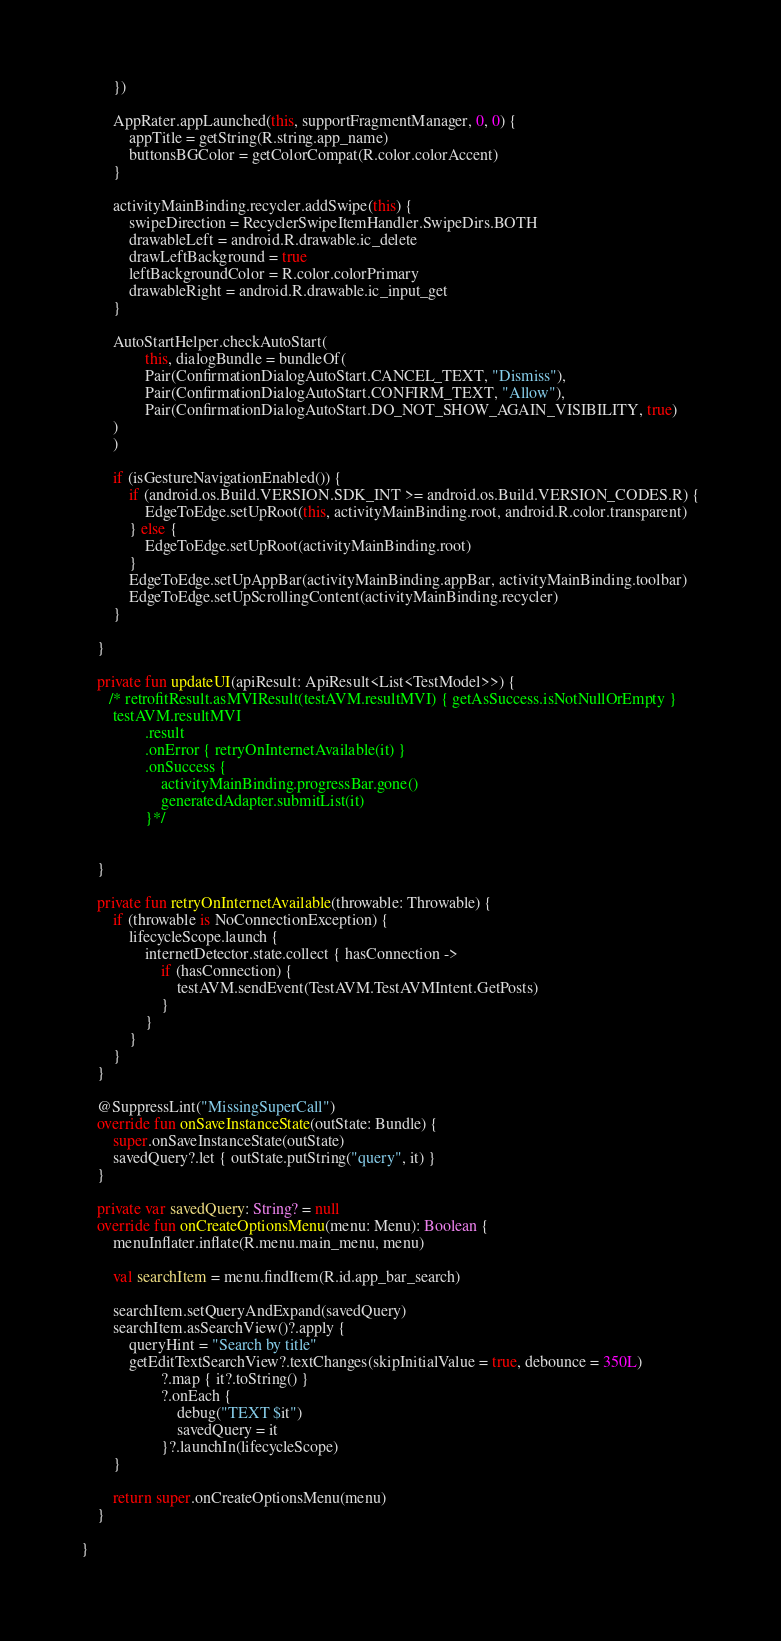Convert code to text. <code><loc_0><loc_0><loc_500><loc_500><_Kotlin_>        })

        AppRater.appLaunched(this, supportFragmentManager, 0, 0) {
            appTitle = getString(R.string.app_name)
            buttonsBGColor = getColorCompat(R.color.colorAccent)
        }

        activityMainBinding.recycler.addSwipe(this) {
            swipeDirection = RecyclerSwipeItemHandler.SwipeDirs.BOTH
            drawableLeft = android.R.drawable.ic_delete
            drawLeftBackground = true
            leftBackgroundColor = R.color.colorPrimary
            drawableRight = android.R.drawable.ic_input_get
        }

        AutoStartHelper.checkAutoStart(
                this, dialogBundle = bundleOf(
                Pair(ConfirmationDialogAutoStart.CANCEL_TEXT, "Dismiss"),
                Pair(ConfirmationDialogAutoStart.CONFIRM_TEXT, "Allow"),
                Pair(ConfirmationDialogAutoStart.DO_NOT_SHOW_AGAIN_VISIBILITY, true)
        )
        )

        if (isGestureNavigationEnabled()) {
            if (android.os.Build.VERSION.SDK_INT >= android.os.Build.VERSION_CODES.R) {
                EdgeToEdge.setUpRoot(this, activityMainBinding.root, android.R.color.transparent)
            } else {
                EdgeToEdge.setUpRoot(activityMainBinding.root)
            }
            EdgeToEdge.setUpAppBar(activityMainBinding.appBar, activityMainBinding.toolbar)
            EdgeToEdge.setUpScrollingContent(activityMainBinding.recycler)
        }

    }

    private fun updateUI(apiResult: ApiResult<List<TestModel>>) {
       /* retrofitResult.asMVIResult(testAVM.resultMVI) { getAsSuccess.isNotNullOrEmpty }
        testAVM.resultMVI
                .result
                .onError { retryOnInternetAvailable(it) }
                .onSuccess {
                    activityMainBinding.progressBar.gone()
                    generatedAdapter.submitList(it)
                }*/


    }

    private fun retryOnInternetAvailable(throwable: Throwable) {
        if (throwable is NoConnectionException) {
            lifecycleScope.launch {
                internetDetector.state.collect { hasConnection ->
                    if (hasConnection) {
                        testAVM.sendEvent(TestAVM.TestAVMIntent.GetPosts)
                    }
                }
            }
        }
    }

    @SuppressLint("MissingSuperCall")
    override fun onSaveInstanceState(outState: Bundle) {
        super.onSaveInstanceState(outState)
        savedQuery?.let { outState.putString("query", it) }
    }

    private var savedQuery: String? = null
    override fun onCreateOptionsMenu(menu: Menu): Boolean {
        menuInflater.inflate(R.menu.main_menu, menu)

        val searchItem = menu.findItem(R.id.app_bar_search)

        searchItem.setQueryAndExpand(savedQuery)
        searchItem.asSearchView()?.apply {
            queryHint = "Search by title"
            getEditTextSearchView?.textChanges(skipInitialValue = true, debounce = 350L)
                    ?.map { it?.toString() }
                    ?.onEach {
                        debug("TEXT $it")
                        savedQuery = it
                    }?.launchIn(lifecycleScope)
        }

        return super.onCreateOptionsMenu(menu)
    }

}








</code> 